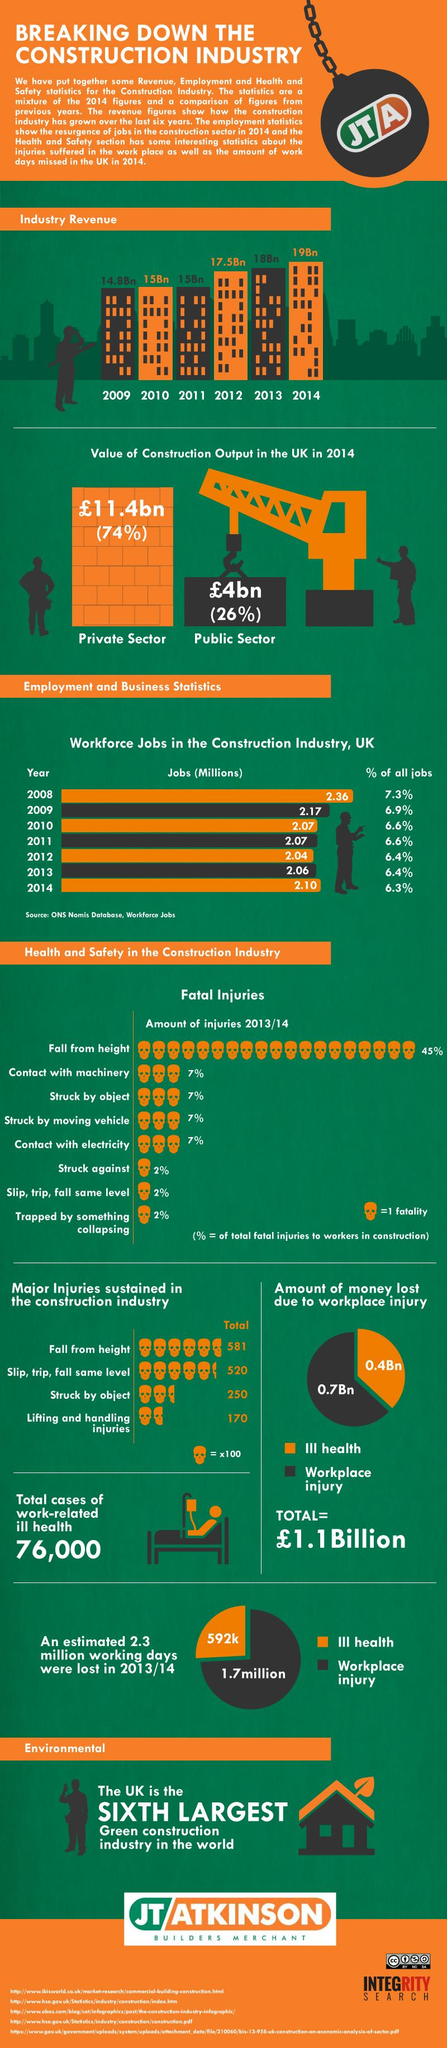List a handful of essential elements in this visual. In the construction industry, struck by object and fall from height are two major types of injuries that result in a significant number of injuries. In particular, 831 major injuries are sustained due to these causes. The revenue generated by the industry from 2009 to 2014 increased by 4.2 billion dollars. In 2013, only 6.4% of all jobs existed. Workplace injury results in more financial loss than ill health. According to studies, three reasons each accounting for 2% of fatal injuries are: being struck by an object, slipping, tripping, or falling from the same level, and being trapped by something that collapses. 